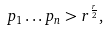<formula> <loc_0><loc_0><loc_500><loc_500>p _ { 1 } \dots p _ { n } > r ^ { \frac { r } { 2 } } ,</formula> 